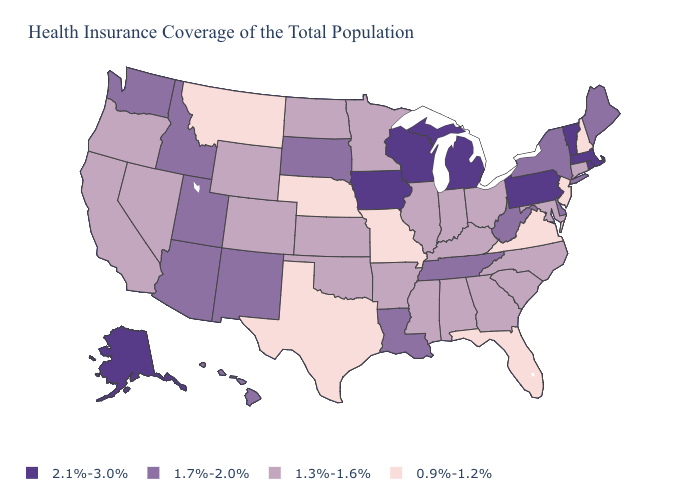Among the states that border Indiana , which have the highest value?
Keep it brief. Michigan. Name the states that have a value in the range 1.3%-1.6%?
Be succinct. Alabama, Arkansas, California, Colorado, Connecticut, Georgia, Illinois, Indiana, Kansas, Kentucky, Maryland, Minnesota, Mississippi, Nevada, North Carolina, North Dakota, Ohio, Oklahoma, Oregon, South Carolina, Wyoming. How many symbols are there in the legend?
Be succinct. 4. Name the states that have a value in the range 1.7%-2.0%?
Quick response, please. Arizona, Delaware, Hawaii, Idaho, Louisiana, Maine, New Mexico, New York, South Dakota, Tennessee, Utah, Washington, West Virginia. Does the map have missing data?
Answer briefly. No. What is the lowest value in states that border North Dakota?
Give a very brief answer. 0.9%-1.2%. Name the states that have a value in the range 1.3%-1.6%?
Write a very short answer. Alabama, Arkansas, California, Colorado, Connecticut, Georgia, Illinois, Indiana, Kansas, Kentucky, Maryland, Minnesota, Mississippi, Nevada, North Carolina, North Dakota, Ohio, Oklahoma, Oregon, South Carolina, Wyoming. What is the value of Wyoming?
Short answer required. 1.3%-1.6%. Which states have the highest value in the USA?
Answer briefly. Alaska, Iowa, Massachusetts, Michigan, Pennsylvania, Rhode Island, Vermont, Wisconsin. Which states hav the highest value in the Northeast?
Short answer required. Massachusetts, Pennsylvania, Rhode Island, Vermont. Does Alaska have the lowest value in the West?
Be succinct. No. Does New Hampshire have the same value as South Carolina?
Give a very brief answer. No. Is the legend a continuous bar?
Quick response, please. No. 